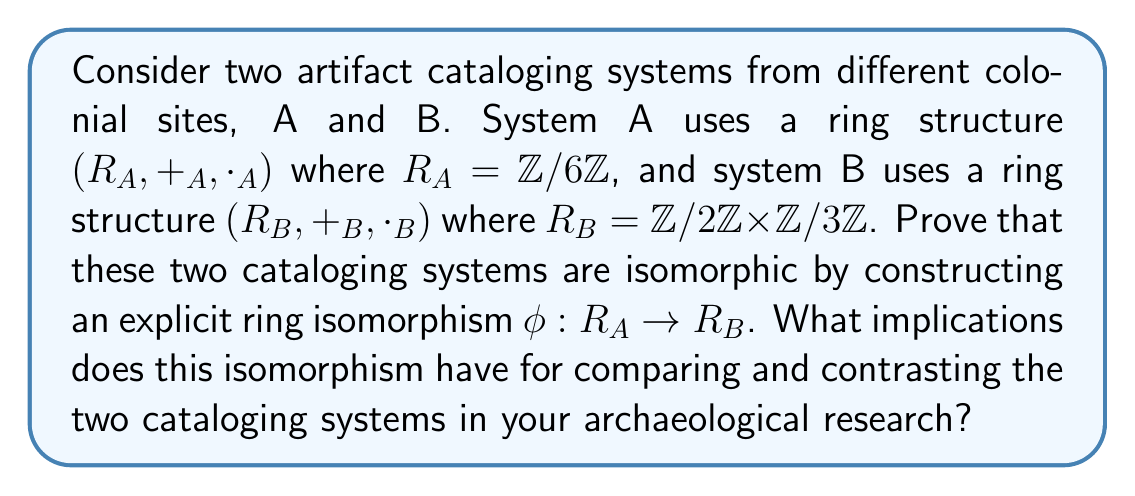Provide a solution to this math problem. To prove that the two cataloging systems are isomorphic, we need to construct a bijective function $\phi: R_A \to R_B$ that preserves both addition and multiplication. Let's approach this step-by-step:

1. First, let's identify the elements of each ring:
   $R_A = \{[0], [1], [2], [3], [4], [5]\}$
   $R_B = \{(0,0), (0,1), (0,2), (1,0), (1,1), (1,2)\}$

2. We can define $\phi: R_A \to R_B$ as follows:
   $\phi([0]) = (0,0)$
   $\phi([1]) = (1,0)$
   $\phi([2]) = (0,2)$
   $\phi([3]) = (1,1)$
   $\phi([4]) = (0,1)$
   $\phi([5]) = (1,2)$

3. To prove this is an isomorphism, we need to show it's bijective and preserves both operations:

   a) Bijectivity: The function maps each element of $R_A$ to a unique element of $R_B$, and every element of $R_B$ is mapped to. Thus, $\phi$ is bijective.

   b) Preserving addition:
      For example, $[2] +_A [3] = [5]$ in $R_A$
      $\phi([2] +_A [3]) = \phi([5]) = (1,2)$
      $\phi([2]) +_B \phi([3]) = (0,2) +_B (1,1) = (1,2)$

   c) Preserving multiplication:
      For example, $[2] \cdot_A [3] = [0]$ in $R_A$
      $\phi([2] \cdot_A [3]) = \phi([0]) = (0,0)$
      $\phi([2]) \cdot_B \phi([3]) = (0,2) \cdot_B (1,1) = (0,0)$

   One can verify that this holds for all pairs of elements.

4. Implications for archaeological research:

   a) Structure equivalence: The isomorphism shows that both cataloging systems have the same underlying algebraic structure, despite appearing different on the surface.

   b) Data translation: It provides a way to translate artifact data between the two systems without loss of information.

   c) Computational efficiency: Operations in one system can be performed equivalently in the other, potentially offering computational advantages.

   d) Historical insights: The isomorphism might reveal historical connections or shared origins between the two colonial sites' cataloging methods.

   e) Standardization potential: Understanding this equivalence could lead to standardizing cataloging systems across different colonial sites.
Answer: The two artifact cataloging systems are isomorphic. The ring isomorphism $\phi: R_A \to R_B$ is given by:
$$\phi([n]) = (n \bmod 2, n \bmod 3)$$
This isomorphism implies that the two cataloging systems have equivalent algebraic structures, allowing for direct comparison, data translation, and potential standardization in archaeological research. 